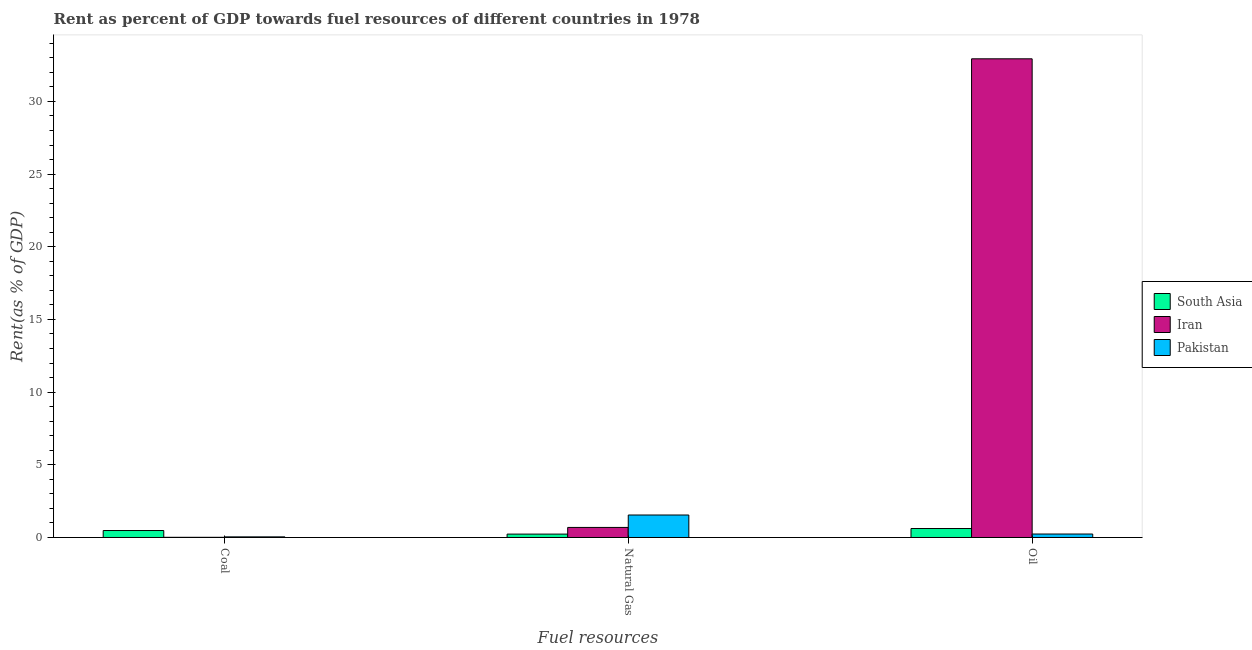How many different coloured bars are there?
Provide a short and direct response. 3. What is the label of the 2nd group of bars from the left?
Your answer should be compact. Natural Gas. What is the rent towards coal in South Asia?
Keep it short and to the point. 0.48. Across all countries, what is the maximum rent towards oil?
Provide a short and direct response. 32.93. Across all countries, what is the minimum rent towards natural gas?
Your answer should be very brief. 0.23. In which country was the rent towards coal maximum?
Your response must be concise. South Asia. In which country was the rent towards natural gas minimum?
Your answer should be compact. South Asia. What is the total rent towards coal in the graph?
Offer a terse response. 0.53. What is the difference between the rent towards oil in Pakistan and that in South Asia?
Your answer should be very brief. -0.38. What is the difference between the rent towards natural gas in Iran and the rent towards oil in South Asia?
Offer a terse response. 0.07. What is the average rent towards oil per country?
Ensure brevity in your answer.  11.26. What is the difference between the rent towards coal and rent towards oil in Pakistan?
Provide a short and direct response. -0.2. In how many countries, is the rent towards oil greater than 3 %?
Provide a short and direct response. 1. What is the ratio of the rent towards natural gas in South Asia to that in Iran?
Keep it short and to the point. 0.34. What is the difference between the highest and the second highest rent towards coal?
Keep it short and to the point. 0.44. What is the difference between the highest and the lowest rent towards natural gas?
Your response must be concise. 1.31. What does the 2nd bar from the right in Coal represents?
Give a very brief answer. Iran. Is it the case that in every country, the sum of the rent towards coal and rent towards natural gas is greater than the rent towards oil?
Your answer should be compact. No. Are all the bars in the graph horizontal?
Offer a terse response. No. Does the graph contain grids?
Your answer should be compact. No. What is the title of the graph?
Your answer should be compact. Rent as percent of GDP towards fuel resources of different countries in 1978. Does "Mozambique" appear as one of the legend labels in the graph?
Your response must be concise. No. What is the label or title of the X-axis?
Your response must be concise. Fuel resources. What is the label or title of the Y-axis?
Provide a succinct answer. Rent(as % of GDP). What is the Rent(as % of GDP) in South Asia in Coal?
Your answer should be very brief. 0.48. What is the Rent(as % of GDP) of Iran in Coal?
Offer a terse response. 0.01. What is the Rent(as % of GDP) of Pakistan in Coal?
Offer a very short reply. 0.04. What is the Rent(as % of GDP) of South Asia in Natural Gas?
Ensure brevity in your answer.  0.23. What is the Rent(as % of GDP) in Iran in Natural Gas?
Offer a terse response. 0.69. What is the Rent(as % of GDP) in Pakistan in Natural Gas?
Offer a very short reply. 1.55. What is the Rent(as % of GDP) in South Asia in Oil?
Your answer should be very brief. 0.62. What is the Rent(as % of GDP) in Iran in Oil?
Offer a very short reply. 32.93. What is the Rent(as % of GDP) in Pakistan in Oil?
Provide a short and direct response. 0.24. Across all Fuel resources, what is the maximum Rent(as % of GDP) of South Asia?
Provide a short and direct response. 0.62. Across all Fuel resources, what is the maximum Rent(as % of GDP) in Iran?
Provide a succinct answer. 32.93. Across all Fuel resources, what is the maximum Rent(as % of GDP) of Pakistan?
Provide a short and direct response. 1.55. Across all Fuel resources, what is the minimum Rent(as % of GDP) in South Asia?
Your answer should be compact. 0.23. Across all Fuel resources, what is the minimum Rent(as % of GDP) of Iran?
Provide a short and direct response. 0.01. Across all Fuel resources, what is the minimum Rent(as % of GDP) in Pakistan?
Keep it short and to the point. 0.04. What is the total Rent(as % of GDP) of South Asia in the graph?
Your answer should be very brief. 1.33. What is the total Rent(as % of GDP) of Iran in the graph?
Give a very brief answer. 33.64. What is the total Rent(as % of GDP) of Pakistan in the graph?
Make the answer very short. 1.83. What is the difference between the Rent(as % of GDP) in South Asia in Coal and that in Natural Gas?
Provide a succinct answer. 0.25. What is the difference between the Rent(as % of GDP) in Iran in Coal and that in Natural Gas?
Give a very brief answer. -0.68. What is the difference between the Rent(as % of GDP) in Pakistan in Coal and that in Natural Gas?
Provide a succinct answer. -1.5. What is the difference between the Rent(as % of GDP) in South Asia in Coal and that in Oil?
Your response must be concise. -0.14. What is the difference between the Rent(as % of GDP) of Iran in Coal and that in Oil?
Provide a short and direct response. -32.92. What is the difference between the Rent(as % of GDP) in Pakistan in Coal and that in Oil?
Keep it short and to the point. -0.2. What is the difference between the Rent(as % of GDP) of South Asia in Natural Gas and that in Oil?
Provide a succinct answer. -0.38. What is the difference between the Rent(as % of GDP) in Iran in Natural Gas and that in Oil?
Your answer should be compact. -32.24. What is the difference between the Rent(as % of GDP) of Pakistan in Natural Gas and that in Oil?
Offer a terse response. 1.31. What is the difference between the Rent(as % of GDP) of South Asia in Coal and the Rent(as % of GDP) of Iran in Natural Gas?
Keep it short and to the point. -0.21. What is the difference between the Rent(as % of GDP) in South Asia in Coal and the Rent(as % of GDP) in Pakistan in Natural Gas?
Your answer should be very brief. -1.07. What is the difference between the Rent(as % of GDP) in Iran in Coal and the Rent(as % of GDP) in Pakistan in Natural Gas?
Keep it short and to the point. -1.53. What is the difference between the Rent(as % of GDP) of South Asia in Coal and the Rent(as % of GDP) of Iran in Oil?
Your answer should be very brief. -32.45. What is the difference between the Rent(as % of GDP) in South Asia in Coal and the Rent(as % of GDP) in Pakistan in Oil?
Offer a very short reply. 0.24. What is the difference between the Rent(as % of GDP) in Iran in Coal and the Rent(as % of GDP) in Pakistan in Oil?
Give a very brief answer. -0.23. What is the difference between the Rent(as % of GDP) in South Asia in Natural Gas and the Rent(as % of GDP) in Iran in Oil?
Provide a short and direct response. -32.7. What is the difference between the Rent(as % of GDP) of South Asia in Natural Gas and the Rent(as % of GDP) of Pakistan in Oil?
Your answer should be very brief. -0.01. What is the difference between the Rent(as % of GDP) in Iran in Natural Gas and the Rent(as % of GDP) in Pakistan in Oil?
Your answer should be compact. 0.45. What is the average Rent(as % of GDP) of South Asia per Fuel resources?
Keep it short and to the point. 0.44. What is the average Rent(as % of GDP) of Iran per Fuel resources?
Give a very brief answer. 11.21. What is the average Rent(as % of GDP) of Pakistan per Fuel resources?
Provide a short and direct response. 0.61. What is the difference between the Rent(as % of GDP) in South Asia and Rent(as % of GDP) in Iran in Coal?
Your answer should be compact. 0.47. What is the difference between the Rent(as % of GDP) of South Asia and Rent(as % of GDP) of Pakistan in Coal?
Offer a terse response. 0.44. What is the difference between the Rent(as % of GDP) in Iran and Rent(as % of GDP) in Pakistan in Coal?
Keep it short and to the point. -0.03. What is the difference between the Rent(as % of GDP) of South Asia and Rent(as % of GDP) of Iran in Natural Gas?
Offer a terse response. -0.46. What is the difference between the Rent(as % of GDP) of South Asia and Rent(as % of GDP) of Pakistan in Natural Gas?
Your answer should be very brief. -1.31. What is the difference between the Rent(as % of GDP) of Iran and Rent(as % of GDP) of Pakistan in Natural Gas?
Give a very brief answer. -0.85. What is the difference between the Rent(as % of GDP) in South Asia and Rent(as % of GDP) in Iran in Oil?
Ensure brevity in your answer.  -32.31. What is the difference between the Rent(as % of GDP) of South Asia and Rent(as % of GDP) of Pakistan in Oil?
Your response must be concise. 0.38. What is the difference between the Rent(as % of GDP) in Iran and Rent(as % of GDP) in Pakistan in Oil?
Make the answer very short. 32.69. What is the ratio of the Rent(as % of GDP) in South Asia in Coal to that in Natural Gas?
Keep it short and to the point. 2.06. What is the ratio of the Rent(as % of GDP) of Iran in Coal to that in Natural Gas?
Your answer should be compact. 0.02. What is the ratio of the Rent(as % of GDP) in Pakistan in Coal to that in Natural Gas?
Provide a succinct answer. 0.03. What is the ratio of the Rent(as % of GDP) in South Asia in Coal to that in Oil?
Keep it short and to the point. 0.78. What is the ratio of the Rent(as % of GDP) of Iran in Coal to that in Oil?
Offer a terse response. 0. What is the ratio of the Rent(as % of GDP) of Pakistan in Coal to that in Oil?
Offer a terse response. 0.18. What is the ratio of the Rent(as % of GDP) of South Asia in Natural Gas to that in Oil?
Your answer should be compact. 0.38. What is the ratio of the Rent(as % of GDP) in Iran in Natural Gas to that in Oil?
Keep it short and to the point. 0.02. What is the ratio of the Rent(as % of GDP) of Pakistan in Natural Gas to that in Oil?
Offer a very short reply. 6.48. What is the difference between the highest and the second highest Rent(as % of GDP) of South Asia?
Offer a very short reply. 0.14. What is the difference between the highest and the second highest Rent(as % of GDP) of Iran?
Provide a succinct answer. 32.24. What is the difference between the highest and the second highest Rent(as % of GDP) of Pakistan?
Provide a succinct answer. 1.31. What is the difference between the highest and the lowest Rent(as % of GDP) in South Asia?
Make the answer very short. 0.38. What is the difference between the highest and the lowest Rent(as % of GDP) in Iran?
Provide a short and direct response. 32.92. What is the difference between the highest and the lowest Rent(as % of GDP) of Pakistan?
Give a very brief answer. 1.5. 